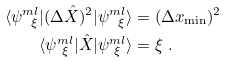Convert formula to latex. <formula><loc_0><loc_0><loc_500><loc_500>\langle \psi ^ { m l } _ { \ \xi } | ( \Delta \hat { X } ) ^ { 2 } | \psi ^ { m l } _ { \ \xi } \rangle & = ( \Delta x _ { \min } ) ^ { 2 } \\ \langle \psi ^ { m l } _ { \ \xi } | \hat { X } | \psi ^ { m l } _ { \ \xi } \rangle & = \xi \ .</formula> 